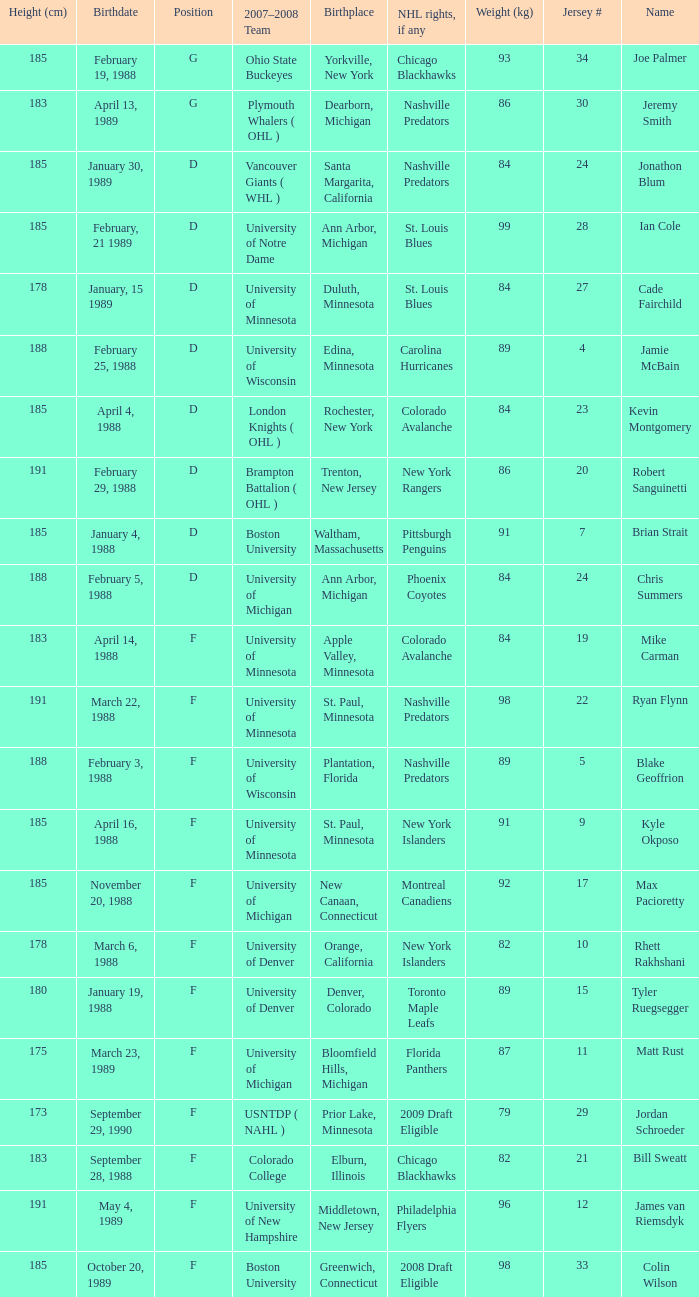Which Weight (kg) has a NHL rights, if any of phoenix coyotes? 1.0. 